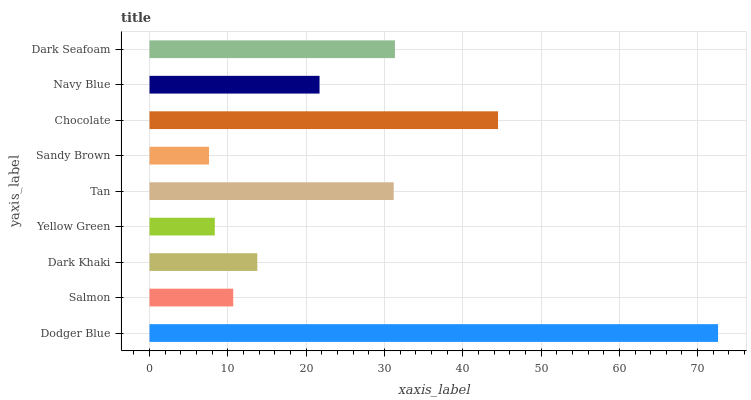Is Sandy Brown the minimum?
Answer yes or no. Yes. Is Dodger Blue the maximum?
Answer yes or no. Yes. Is Salmon the minimum?
Answer yes or no. No. Is Salmon the maximum?
Answer yes or no. No. Is Dodger Blue greater than Salmon?
Answer yes or no. Yes. Is Salmon less than Dodger Blue?
Answer yes or no. Yes. Is Salmon greater than Dodger Blue?
Answer yes or no. No. Is Dodger Blue less than Salmon?
Answer yes or no. No. Is Navy Blue the high median?
Answer yes or no. Yes. Is Navy Blue the low median?
Answer yes or no. Yes. Is Dodger Blue the high median?
Answer yes or no. No. Is Sandy Brown the low median?
Answer yes or no. No. 